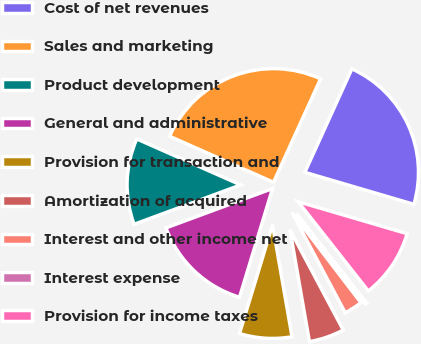Convert chart. <chart><loc_0><loc_0><loc_500><loc_500><pie_chart><fcel>Cost of net revenues<fcel>Sales and marketing<fcel>Product development<fcel>General and administrative<fcel>Provision for transaction and<fcel>Amortization of acquired<fcel>Interest and other income net<fcel>Interest expense<fcel>Provision for income taxes<nl><fcel>22.75%<fcel>25.16%<fcel>12.26%<fcel>14.67%<fcel>7.44%<fcel>5.03%<fcel>2.62%<fcel>0.21%<fcel>9.85%<nl></chart> 